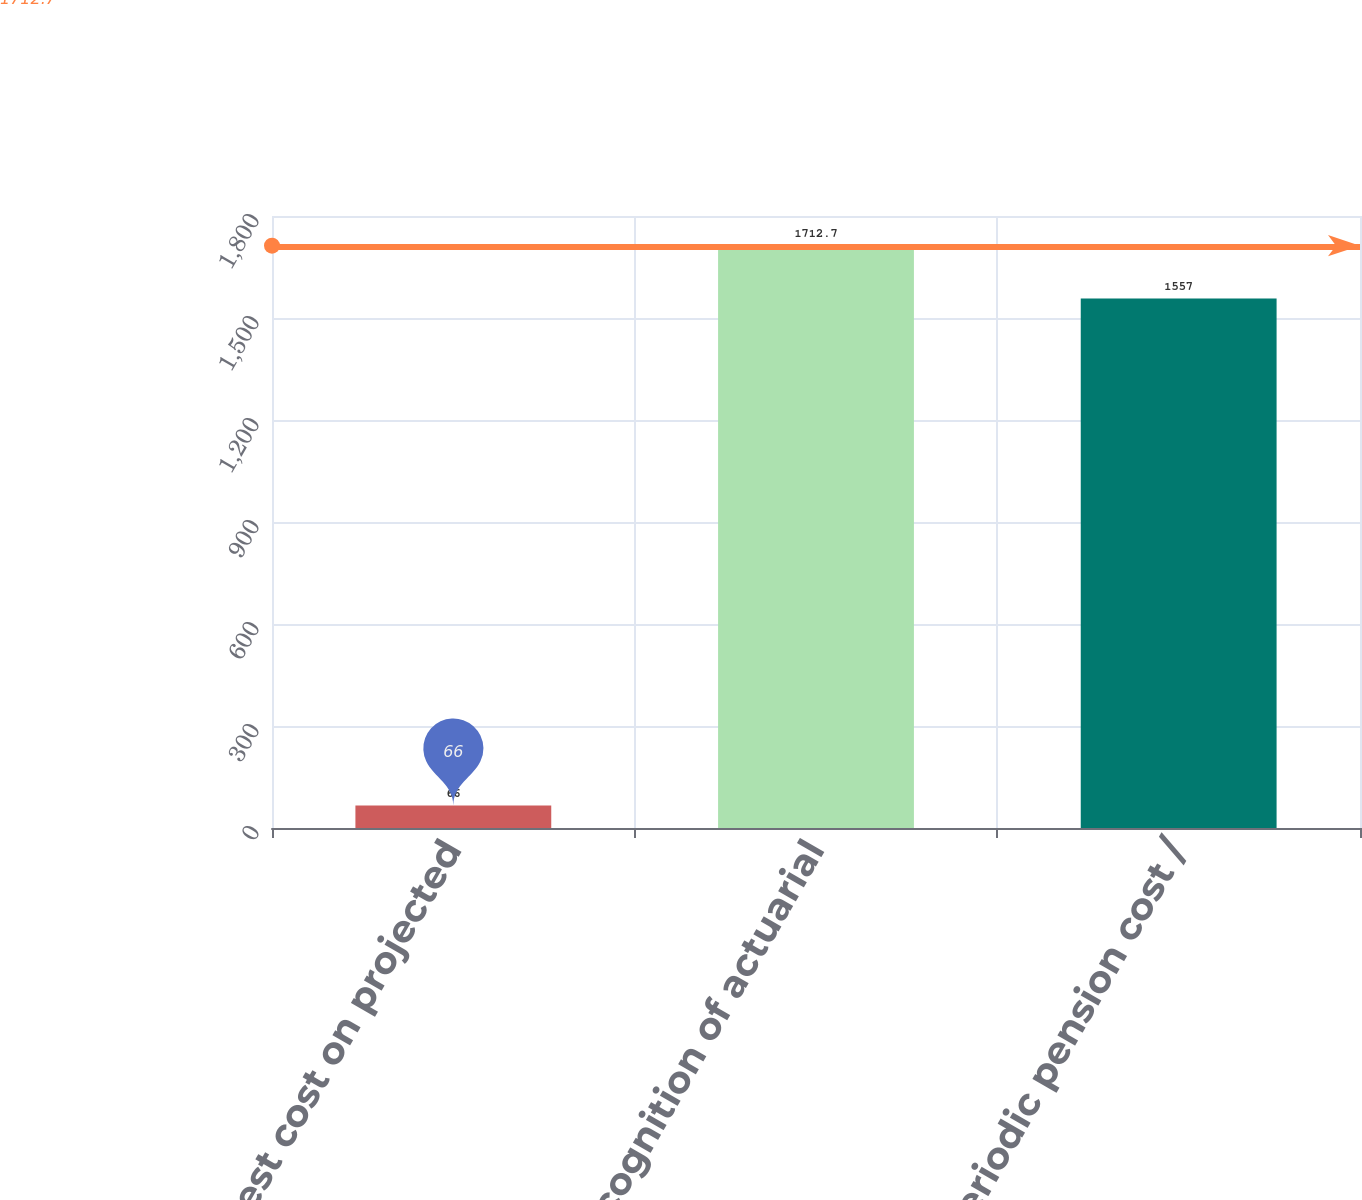Convert chart. <chart><loc_0><loc_0><loc_500><loc_500><bar_chart><fcel>Interest cost on projected<fcel>Recognition of actuarial<fcel>Net periodic pension cost /<nl><fcel>66<fcel>1712.7<fcel>1557<nl></chart> 